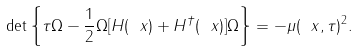<formula> <loc_0><loc_0><loc_500><loc_500>\det \left \{ \tau \Omega - \frac { 1 } { 2 } \Omega [ H ( \ x ) + H ^ { \dagger } ( \ x ) ] \Omega \right \} = - \mu ( \ x , \tau ) ^ { 2 } .</formula> 